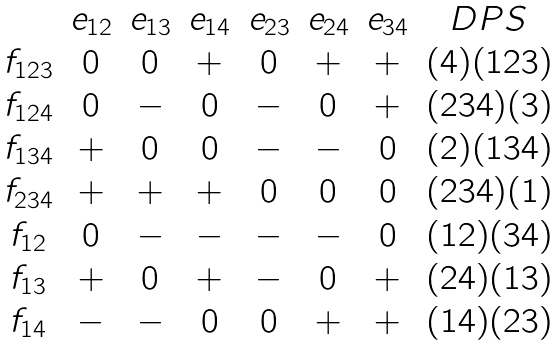Convert formula to latex. <formula><loc_0><loc_0><loc_500><loc_500>\begin{matrix} & e _ { 1 2 } & e _ { 1 3 } & e _ { 1 4 } & e _ { 2 3 } & e _ { 2 4 } & e _ { 3 4 } & D P S \\ f _ { 1 2 3 } & 0 & 0 & + & 0 & + & + & ( 4 ) ( 1 2 3 ) \\ f _ { 1 2 4 } & 0 & - & 0 & - & 0 & + & ( 2 3 4 ) ( 3 ) \\ f _ { 1 3 4 } & + & 0 & 0 & - & - & 0 & ( 2 ) ( 1 3 4 ) \\ f _ { 2 3 4 } & + & + & + & 0 & 0 & 0 & ( 2 3 4 ) ( 1 ) \\ f _ { 1 2 } & 0 & - & - & - & - & 0 & ( 1 2 ) ( 3 4 ) \\ f _ { 1 3 } & + & 0 & + & - & 0 & + & ( 2 4 ) ( 1 3 ) \\ f _ { 1 4 } & - & - & 0 & 0 & + & + & ( 1 4 ) ( 2 3 ) \end{matrix}</formula> 